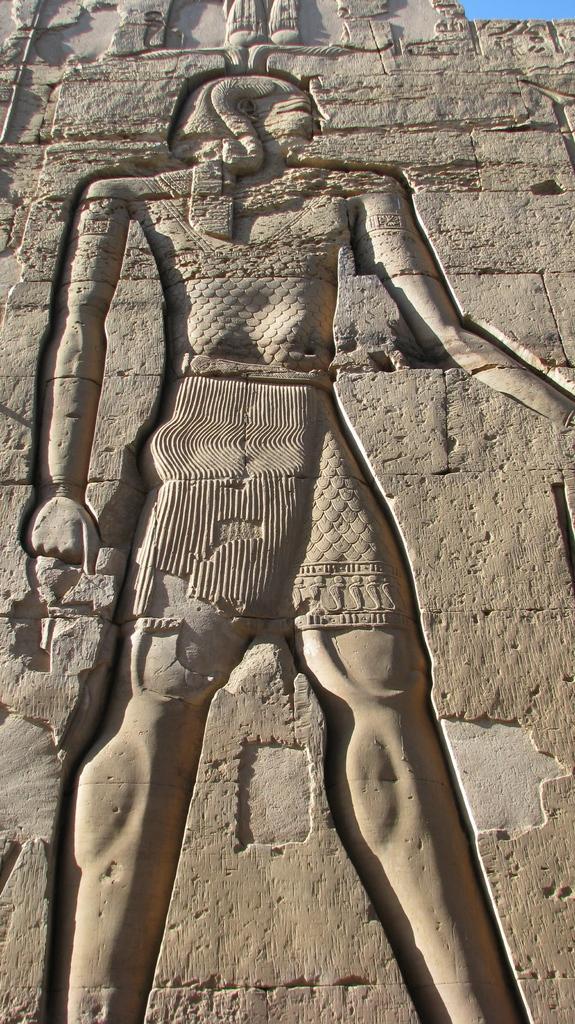Please provide a concise description of this image. There is a sculpture on a wall. In the background, there is blue sky. 